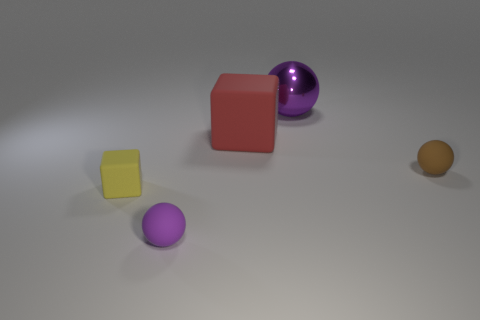There is a tiny yellow matte block; are there any large red objects in front of it?
Offer a very short reply. No. Are there the same number of shiny objects on the right side of the large shiny thing and large red objects to the right of the tiny brown rubber ball?
Your response must be concise. Yes. There is a purple thing that is in front of the brown rubber ball; does it have the same size as the purple object that is behind the tiny yellow object?
Give a very brief answer. No. What is the shape of the object that is to the left of the matte sphere to the left of the thing right of the purple shiny object?
Offer a terse response. Cube. Are there any other things that are the same material as the big block?
Make the answer very short. Yes. The brown rubber object that is the same shape as the purple rubber thing is what size?
Your response must be concise. Small. What is the color of the small rubber object that is behind the purple matte ball and on the right side of the small yellow rubber thing?
Your response must be concise. Brown. Are the large red object and the small object that is behind the yellow rubber object made of the same material?
Make the answer very short. Yes. Are there fewer small cubes right of the small brown rubber ball than purple metallic cylinders?
Provide a short and direct response. No. What number of other things are the same shape as the small purple object?
Ensure brevity in your answer.  2. 